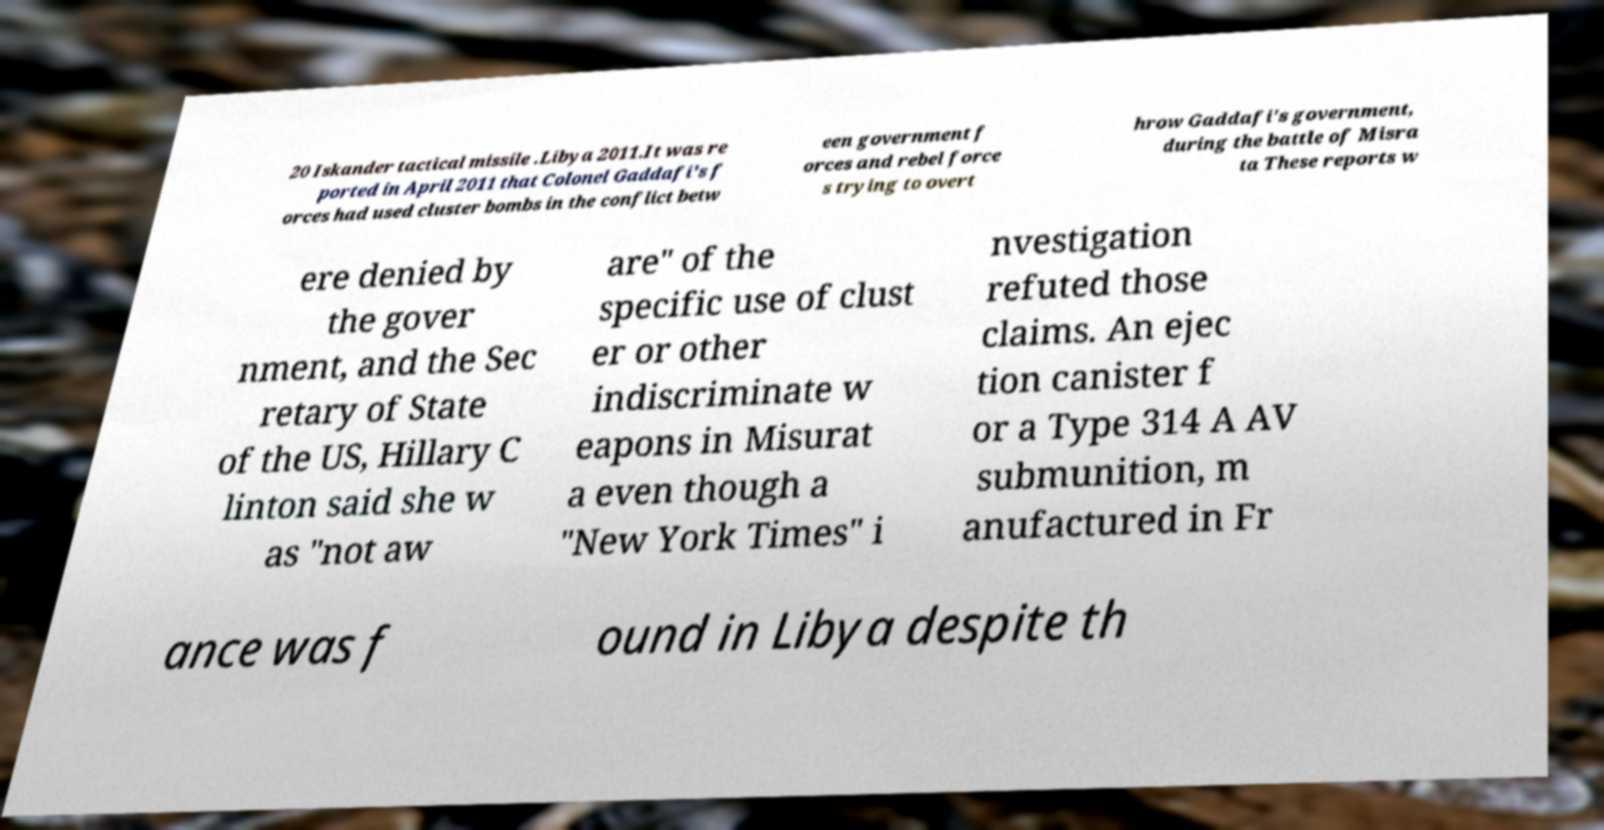Can you read and provide the text displayed in the image?This photo seems to have some interesting text. Can you extract and type it out for me? 20 Iskander tactical missile .Libya 2011.It was re ported in April 2011 that Colonel Gaddafi's f orces had used cluster bombs in the conflict betw een government f orces and rebel force s trying to overt hrow Gaddafi's government, during the battle of Misra ta These reports w ere denied by the gover nment, and the Sec retary of State of the US, Hillary C linton said she w as "not aw are" of the specific use of clust er or other indiscriminate w eapons in Misurat a even though a "New York Times" i nvestigation refuted those claims. An ejec tion canister f or a Type 314 A AV submunition, m anufactured in Fr ance was f ound in Libya despite th 